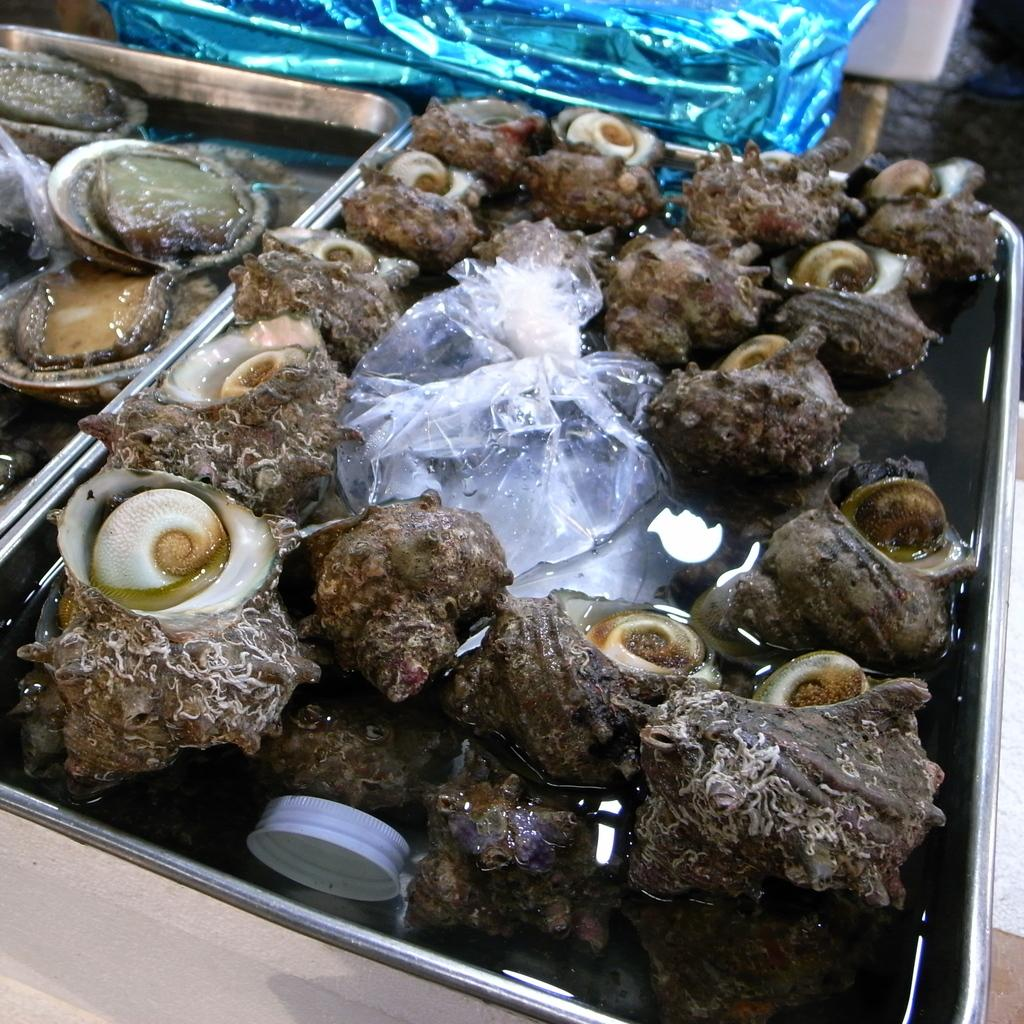What objects can be seen in the image? There are sea shells in the image. How are the sea shells arranged or organized? The sea shells are placed in a tray. What type of cannon is present in the image? There is no cannon present in the image; it features sea shells placed in a tray. 